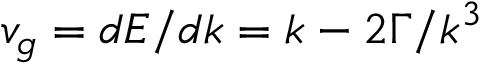<formula> <loc_0><loc_0><loc_500><loc_500>v _ { g } = d E / d k = k - 2 \Gamma / k ^ { 3 }</formula> 